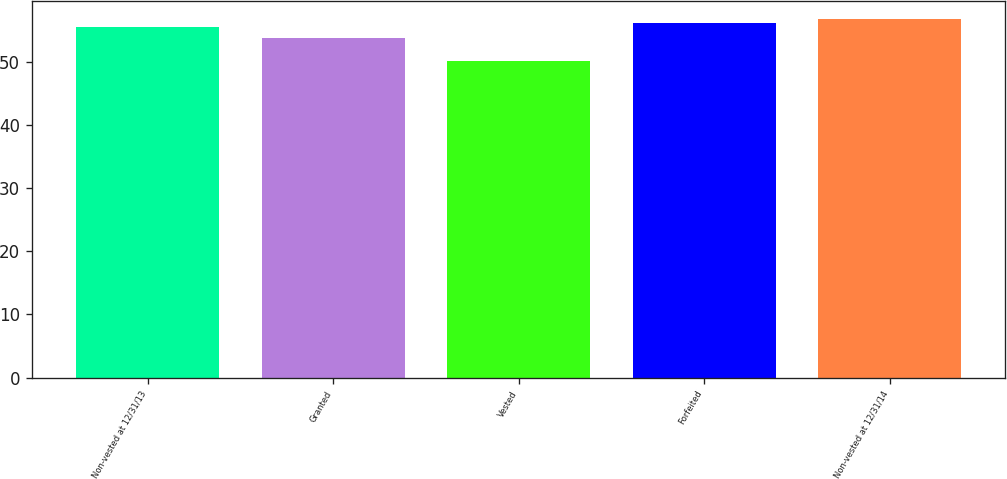Convert chart to OTSL. <chart><loc_0><loc_0><loc_500><loc_500><bar_chart><fcel>Non-vested at 12/31/13<fcel>Granted<fcel>Vested<fcel>Forfeited<fcel>Non-vested at 12/31/14<nl><fcel>55.42<fcel>53.71<fcel>50.08<fcel>56.08<fcel>56.74<nl></chart> 